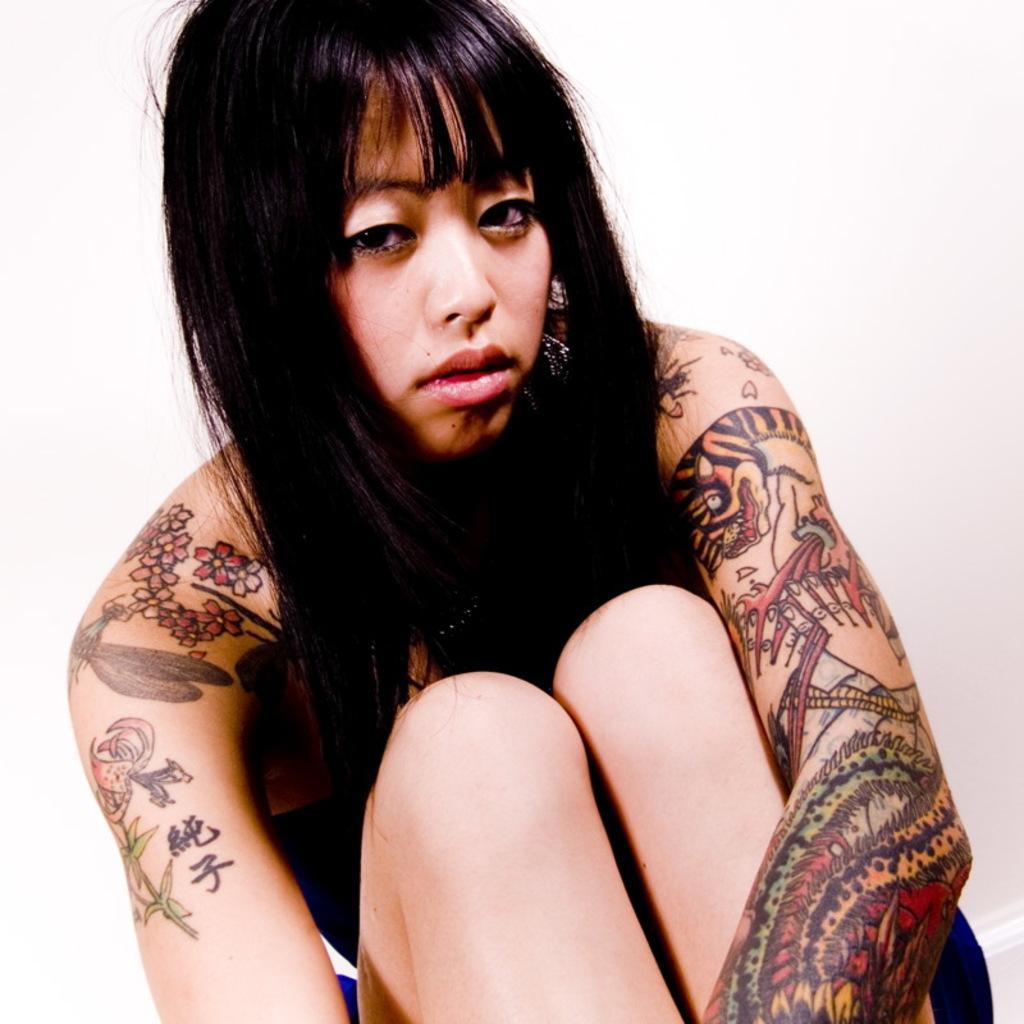How would you summarize this image in a sentence or two? In this image we can see a person. On the person body we can see the tattoos. The background of the image is white. 